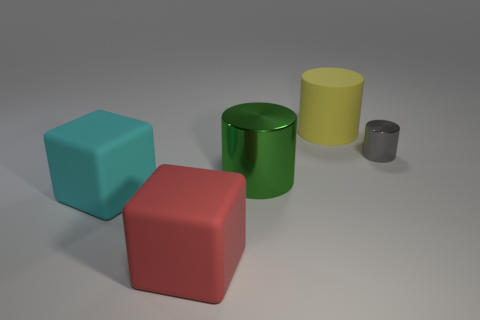Add 1 yellow rubber things. How many objects exist? 6 Subtract all cylinders. How many objects are left? 2 Subtract all cylinders. Subtract all red blocks. How many objects are left? 1 Add 4 big rubber cylinders. How many big rubber cylinders are left? 5 Add 2 large yellow matte objects. How many large yellow matte objects exist? 3 Subtract 1 green cylinders. How many objects are left? 4 